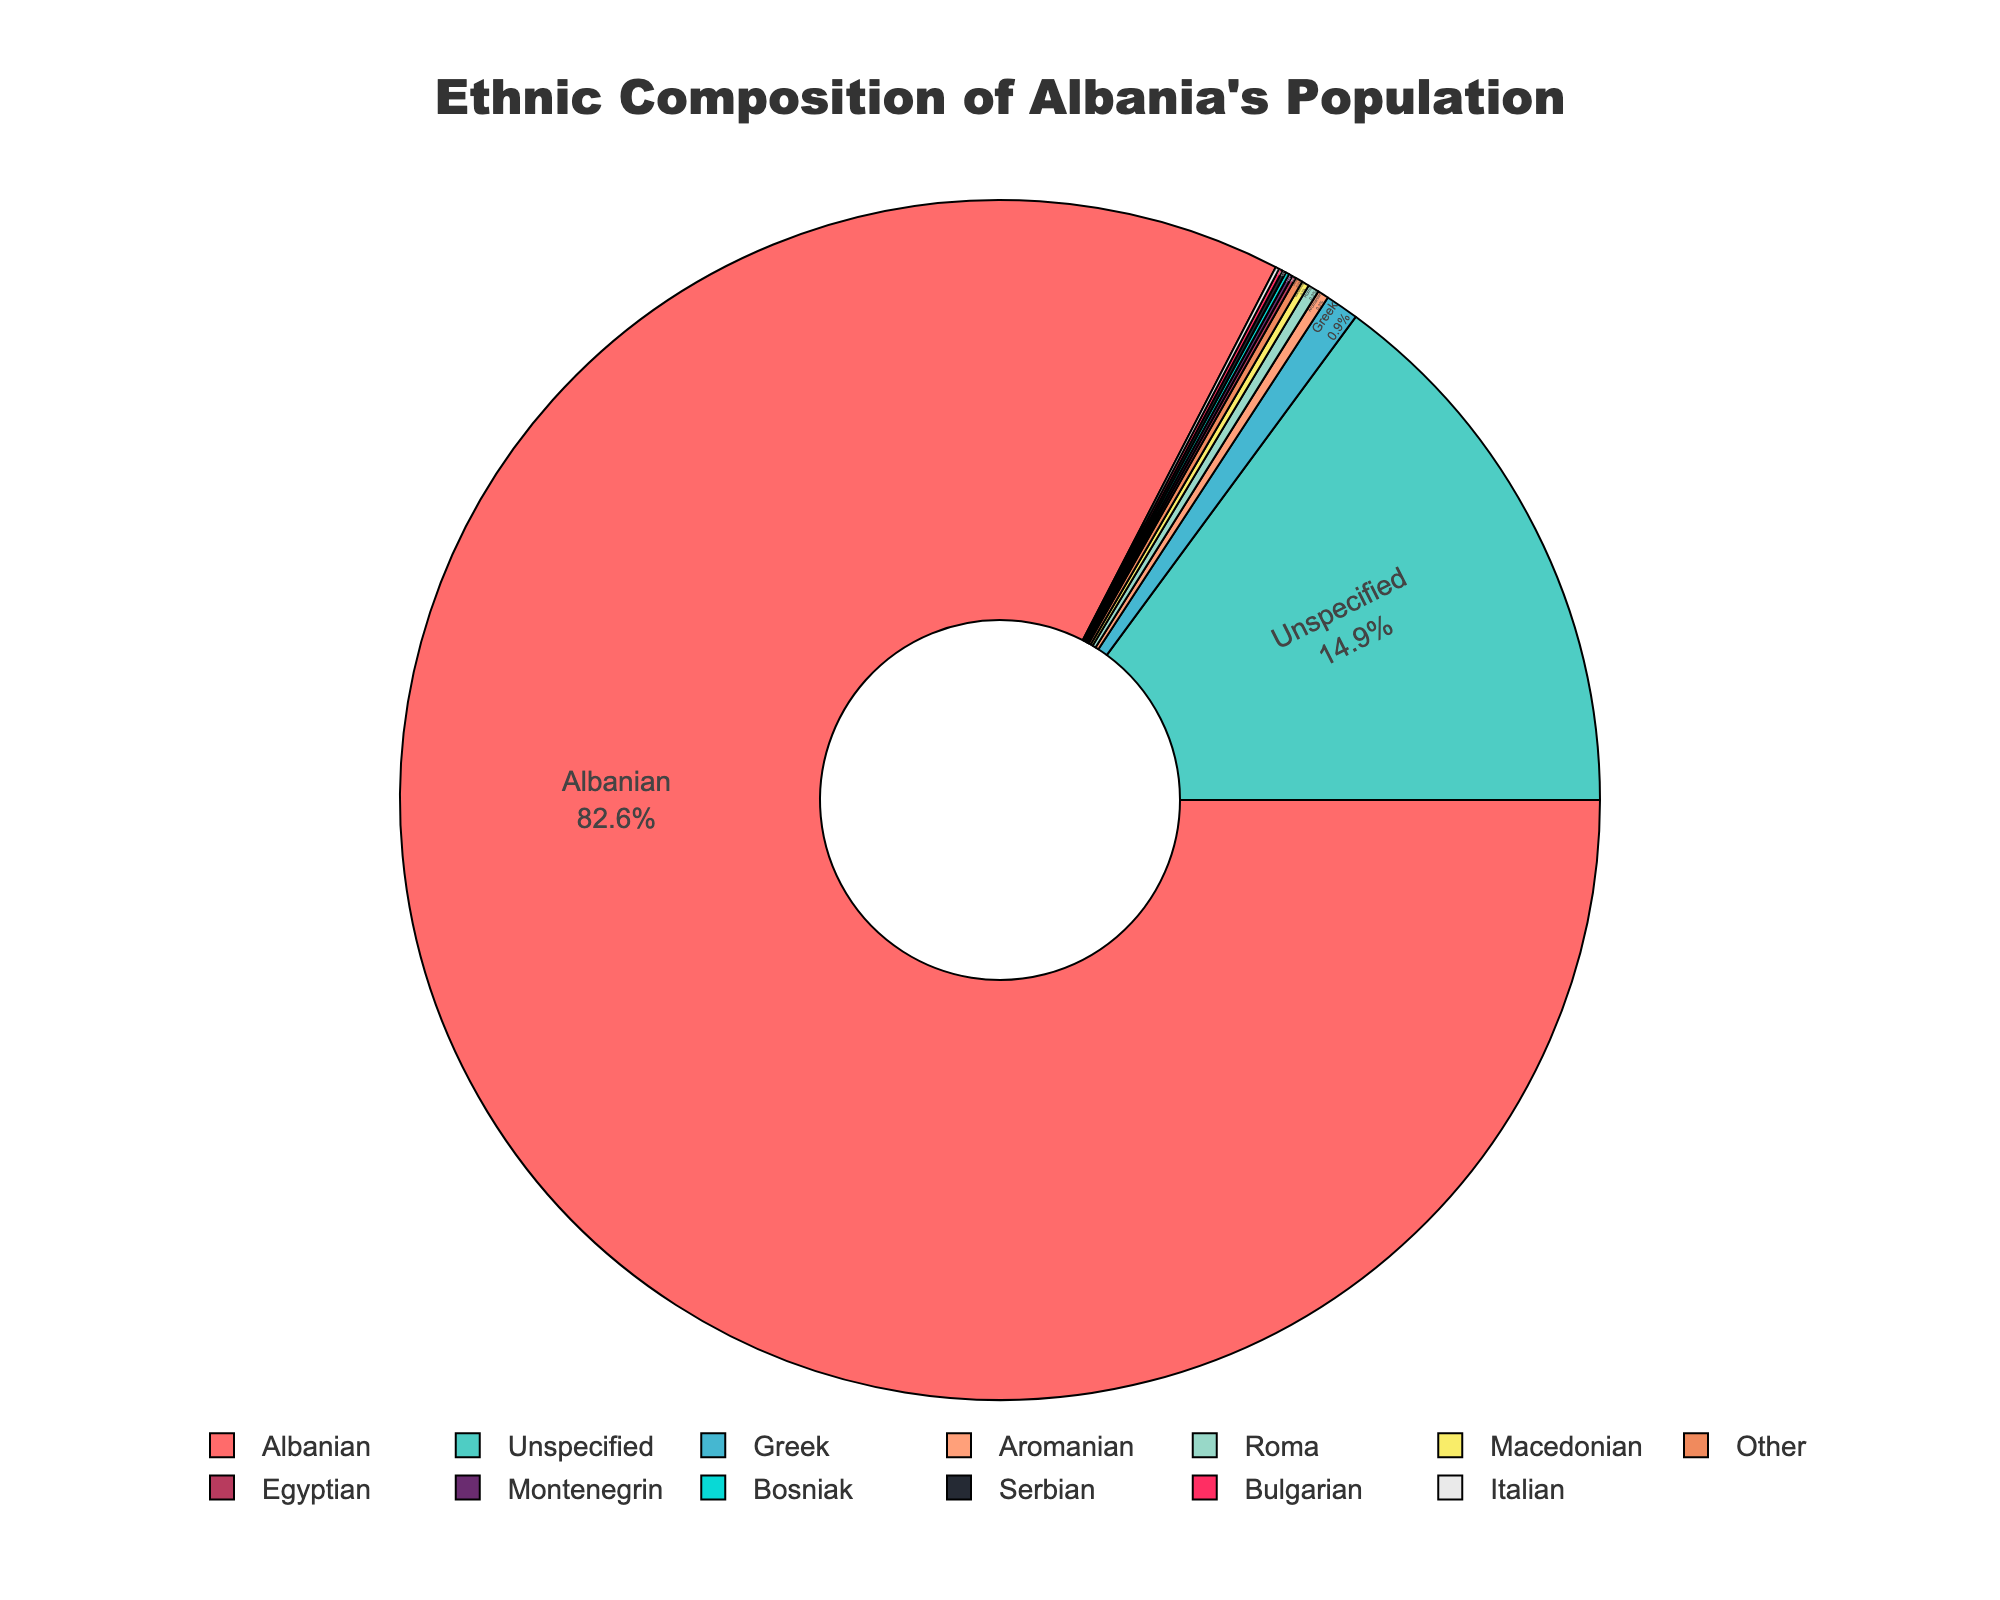How many ethnic groups have a percentage higher than 1% in Albania’s population? Looking at the pie chart, only the 'Albanian' group has a percentage higher than 1%. The rest of the ethnic groups have percentages less than or equal to 1%.
Answer: 1 Which ethnic group represents the second largest proportion of the population? By examining the pie chart, after 'Albanian' (82.6%), 'Unspecified' is the next largest category at 14.9%.
Answer: Unspecified What is the combined percentage of the 'Greek' and 'Aromanian' populations? Look at the chart to find the percentage of 'Greek' (0.9%) and 'Aromanian' (0.3%). Adding them together gives 0.9 + 0.3 = 1.2%.
Answer: 1.2% Are there any ethnic groups represented by the same percentage in Albania? If yes, which ones are they? Scanning the pie chart, 'Aromanian', 'Roma', and 'Other' each have a percentage of 0.3%. Additionally, 'Macedonian', 'Unspecified', 'Bosniak', and 'Serbian' each share 0.1%.
Answer: Aromanian, Roma, Other; Macedonian, Unspecified, Bosniak, Serbian Which ethnic group is represented in blue color? By observing the colors used in the pie chart, 'Aromanian' is represented in blue color.
Answer: Aromanian What is the total percentage of ethnic groups other than 'Albanian' and 'Unspecified'? First, sum all percentages except 'Albanian' and 'Unspecified'. These groups total to: 100% - (82.6% + 14.9%) = 2.5%.
Answer: 2.5% By how much is the 'Albanian' population larger than the 'Greek' population? The proportion of 'Albanian' is 82.6% and 'Greek' is 0.9%. The difference is 82.6 - 0.9 = 81.7%.
Answer: 81.7% What's the average percentage of the three smallest ethnic groups? The three smallest ethnic groups are 'Bushnak', 'Serbian', and 'Montenegrin', each with 0.1%. The average percentage is (0.1 + 0.1 + 0.1) / 3 = 0.1%.
Answer: 0.1% Which ethnic group is depicted just next to 'Albanian' counterclockwise? Observing the chart, just counterclockwise to 'Albanian' is 'Unspecified'.
Answer: Unspecified 